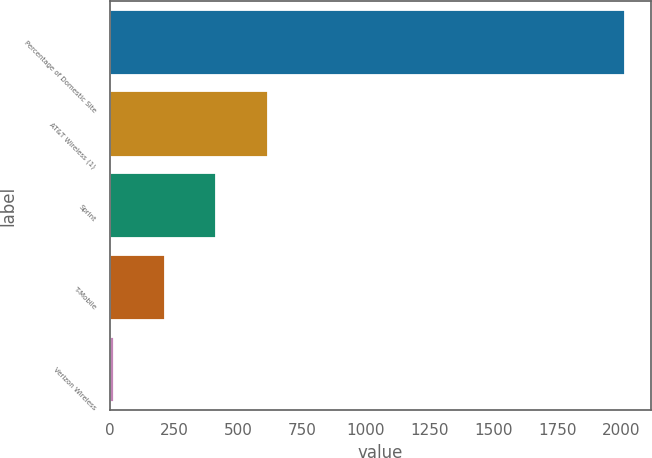Convert chart. <chart><loc_0><loc_0><loc_500><loc_500><bar_chart><fcel>Percentage of Domestic Site<fcel>AT&T Wireless (1)<fcel>Sprint<fcel>T-Mobile<fcel>Verizon Wireless<nl><fcel>2015<fcel>615.91<fcel>416.04<fcel>216.17<fcel>16.3<nl></chart> 